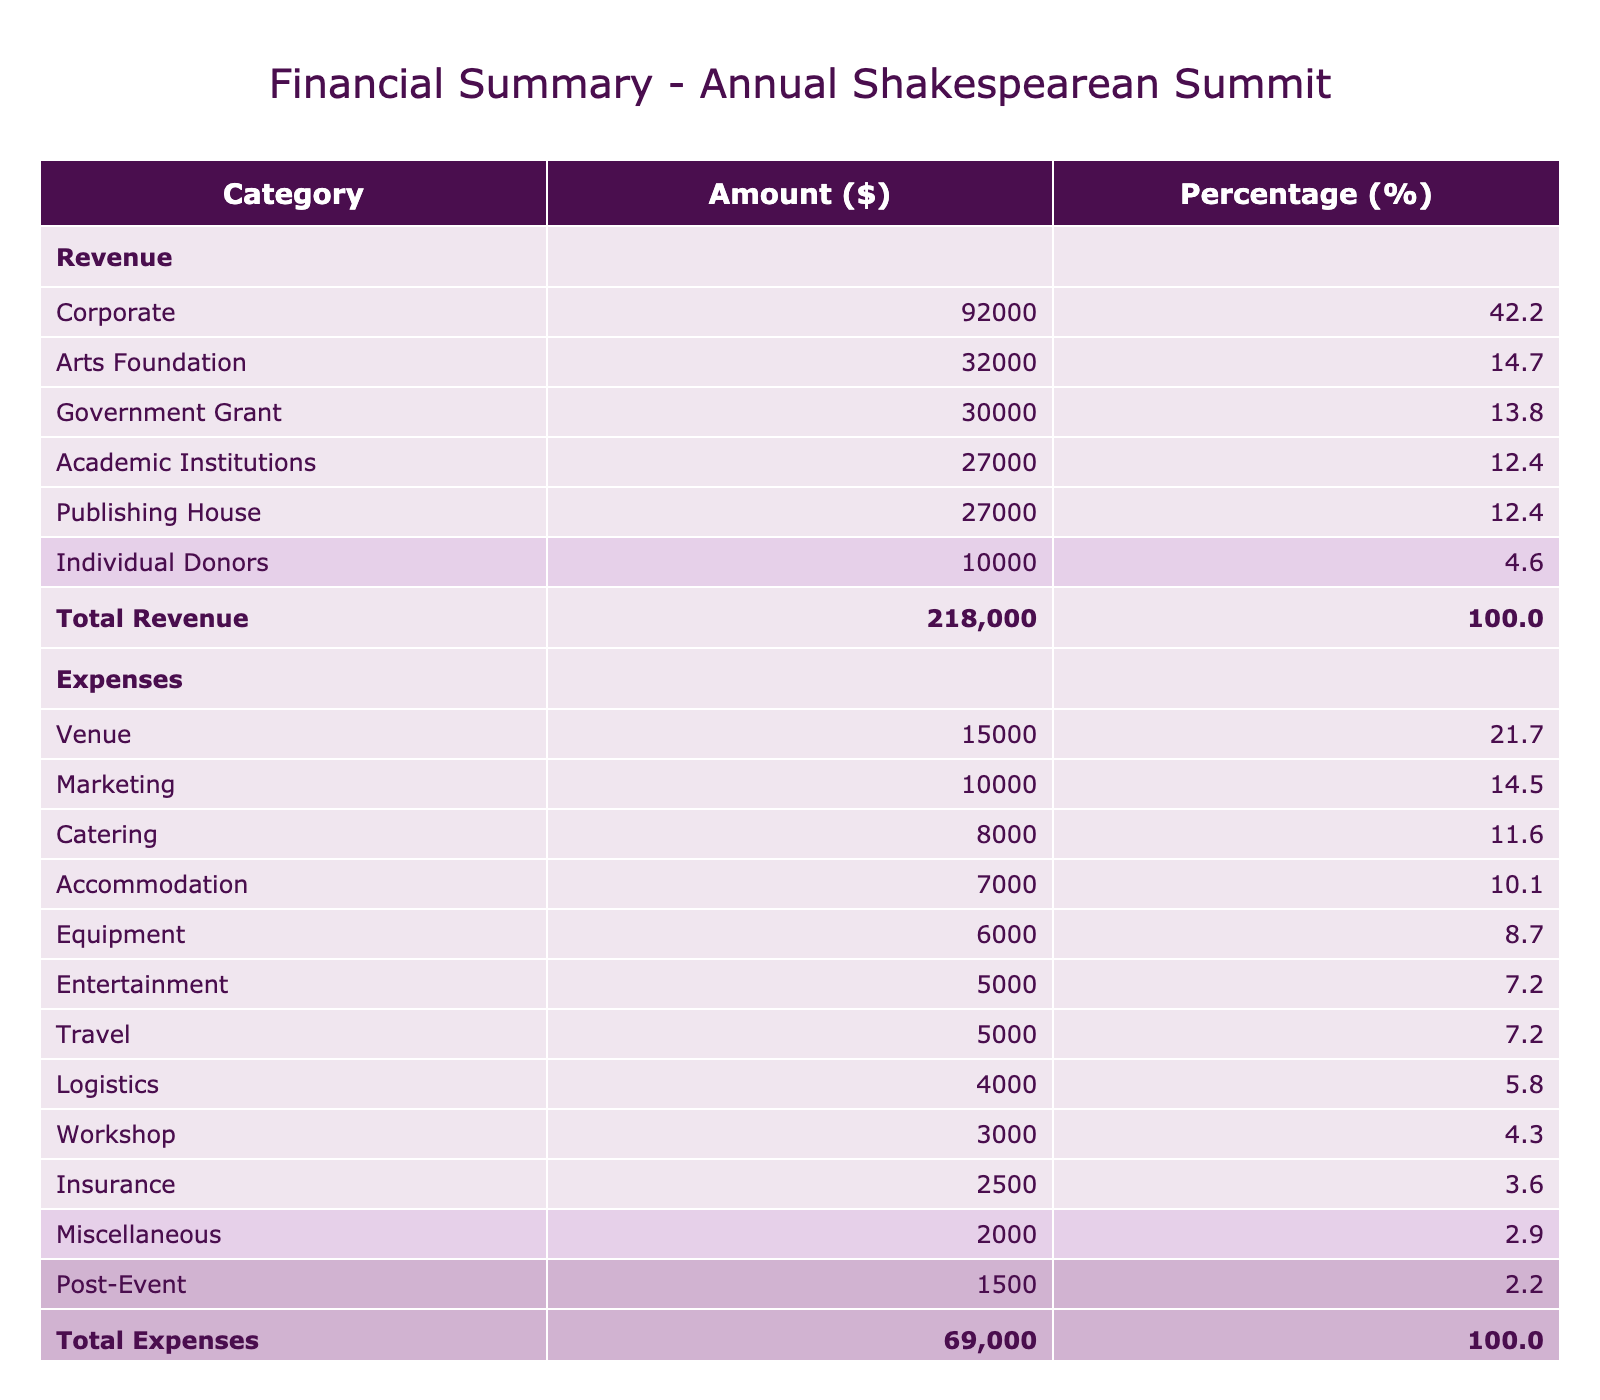What is the total sponsorship revenue from all sponsors? To find the total sponsorship revenue, I sum all the amounts listed under "Sponsorship Contribution." The values are 25000, 15000, 18000, 20000, 30000, 30000, 10000, 15000, 12000, 9000, 22000, and 12000. The total is 25000 + 15000 + 18000 + 20000 + 30000 + 30000 + 10000 + 15000 + 12000 + 9000 + 22000 + 12000 = 181000.
Answer: 181000 What is the total amount spent on catering? The expense category for catering lists the amount for "Lunch and Coffee Breaks" as 8000. This is the only expense under catering, which means that the total amount spent on catering is 8000.
Answer: 8000 Which sponsorship category had the highest revenue? To determine the highest revenue category, I look at the total sponsorship contributions for each category. Corporate sponsorship has contributions totaling 100000 (25000 + 30000 + 15000 + 22000) which is higher than Academic Institutions (27000), Publishing House (27000), Arts Foundation (32000), and Government Grant (30000). Therefore, Corporate had the highest revenue.
Answer: Corporate What percentage of the total expenses is spent on accommodation? The total expenses amount to 57000. The amount listed under accommodation is 7000. To find the percentage, I calculate (7000 / 57000) * 100, which equals approximately 12.28%.
Answer: 12.28 Is the net profit greater than 100000? To determine this, I first calculate the net profit by subtracting the total expenses (57000) from the total revenue (181000). The net profit is 181000 - 57000 = 124000. Since 124000 is greater than 100000, the answer is yes.
Answer: Yes What is the average sponsorship contribution from Academic Institutions? The total sponsorship contribution from Academic Institutions is 15000 (from Oxford University Press) + 12000 (from Harvard University) = 27000. There are 2 sponsors in this category, so the average is calculated as 27000 / 2 = 13500.
Answer: 13500 How much was spent on logistics compared to entertainment? The total amount spent on logistics is 4000, while the total spent on entertainment is 5000. To compare, we see that entertainment spending is 5000 - 4000 = 1000 more than logistics.
Answer: 1000 Which sponsor contributed the least? The smallest contribution among the sponsors is from Pearson Education, which contributed 9000.
Answer: 9000 What is the difference between total revenue and total expenses? The total revenue is 181000, and the total expenses are 57000. The difference is calculated by subtracting total expenses from total revenue: 181000 - 57000 = 124000.
Answer: 124000 